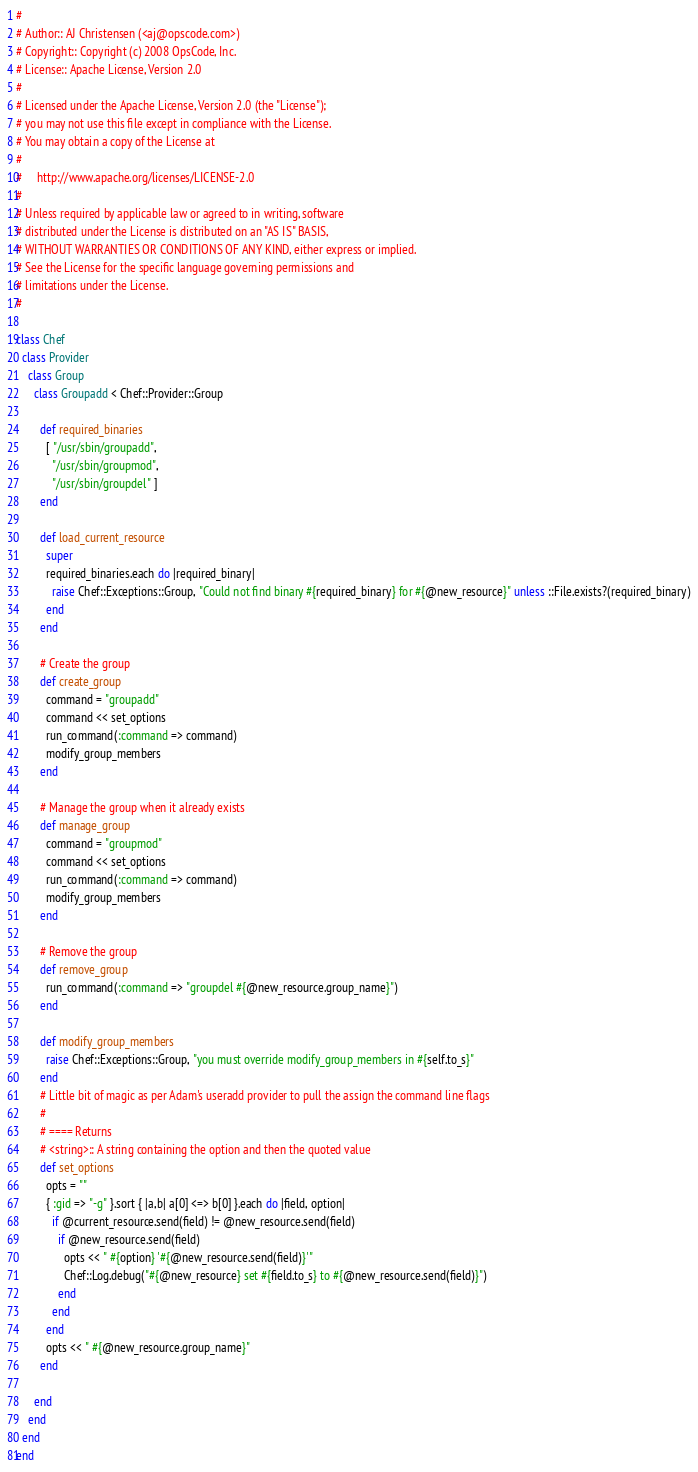<code> <loc_0><loc_0><loc_500><loc_500><_Ruby_>#
# Author:: AJ Christensen (<aj@opscode.com>)
# Copyright:: Copyright (c) 2008 OpsCode, Inc.
# License:: Apache License, Version 2.0
#
# Licensed under the Apache License, Version 2.0 (the "License");
# you may not use this file except in compliance with the License.
# You may obtain a copy of the License at
# 
#     http://www.apache.org/licenses/LICENSE-2.0
# 
# Unless required by applicable law or agreed to in writing, software
# distributed under the License is distributed on an "AS IS" BASIS,
# WITHOUT WARRANTIES OR CONDITIONS OF ANY KIND, either express or implied.
# See the License for the specific language governing permissions and
# limitations under the License.
#

class Chef
  class Provider
    class Group
      class Groupadd < Chef::Provider::Group
        
        def required_binaries
          [ "/usr/sbin/groupadd",
            "/usr/sbin/groupmod",
            "/usr/sbin/groupdel" ]
        end

        def load_current_resource
          super
          required_binaries.each do |required_binary|
            raise Chef::Exceptions::Group, "Could not find binary #{required_binary} for #{@new_resource}" unless ::File.exists?(required_binary)
          end
        end

        # Create the group
        def create_group
          command = "groupadd"
          command << set_options
          run_command(:command => command)
          modify_group_members    
        end
        
        # Manage the group when it already exists
        def manage_group
          command = "groupmod"
          command << set_options
          run_command(:command => command)
          modify_group_members
        end
        
        # Remove the group
        def remove_group
          run_command(:command => "groupdel #{@new_resource.group_name}")
        end
        
        def modify_group_members
          raise Chef::Exceptions::Group, "you must override modify_group_members in #{self.to_s}"
        end
        # Little bit of magic as per Adam's useradd provider to pull the assign the command line flags
        #
        # ==== Returns
        # <string>:: A string containing the option and then the quoted value
        def set_options
          opts = ""
          { :gid => "-g" }.sort { |a,b| a[0] <=> b[0] }.each do |field, option|
            if @current_resource.send(field) != @new_resource.send(field)
              if @new_resource.send(field)
                opts << " #{option} '#{@new_resource.send(field)}'"
                Chef::Log.debug("#{@new_resource} set #{field.to_s} to #{@new_resource.send(field)}")
              end
            end
          end
          opts << " #{@new_resource.group_name}"
        end
        
      end
    end
  end
end
</code> 